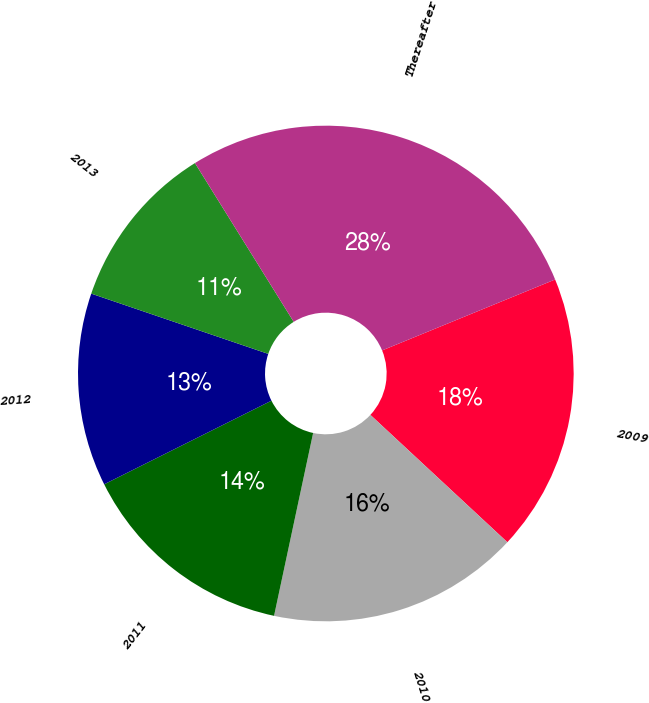Convert chart. <chart><loc_0><loc_0><loc_500><loc_500><pie_chart><fcel>2009<fcel>2010<fcel>2011<fcel>2012<fcel>2013<fcel>Thereafter<nl><fcel>18.11%<fcel>16.43%<fcel>14.27%<fcel>12.6%<fcel>10.92%<fcel>27.66%<nl></chart> 